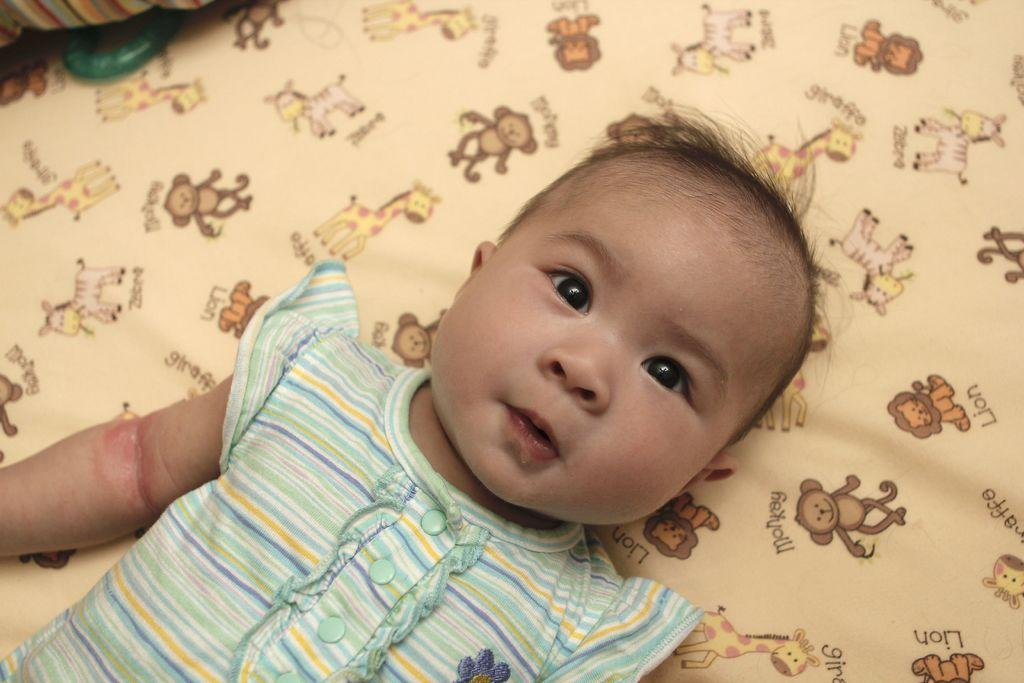What is the child doing in the image? The child is laying on the cloth. What is depicted on the cloth? There are pictures of animals on the cloth. Are the names of the animals visible on the cloth? Yes, the names of the animals are visible on the cloth. What type of honey is being used to write the names of the animals on the cloth? There is no honey present in the image, and the names of the animals are not being written on the cloth. 